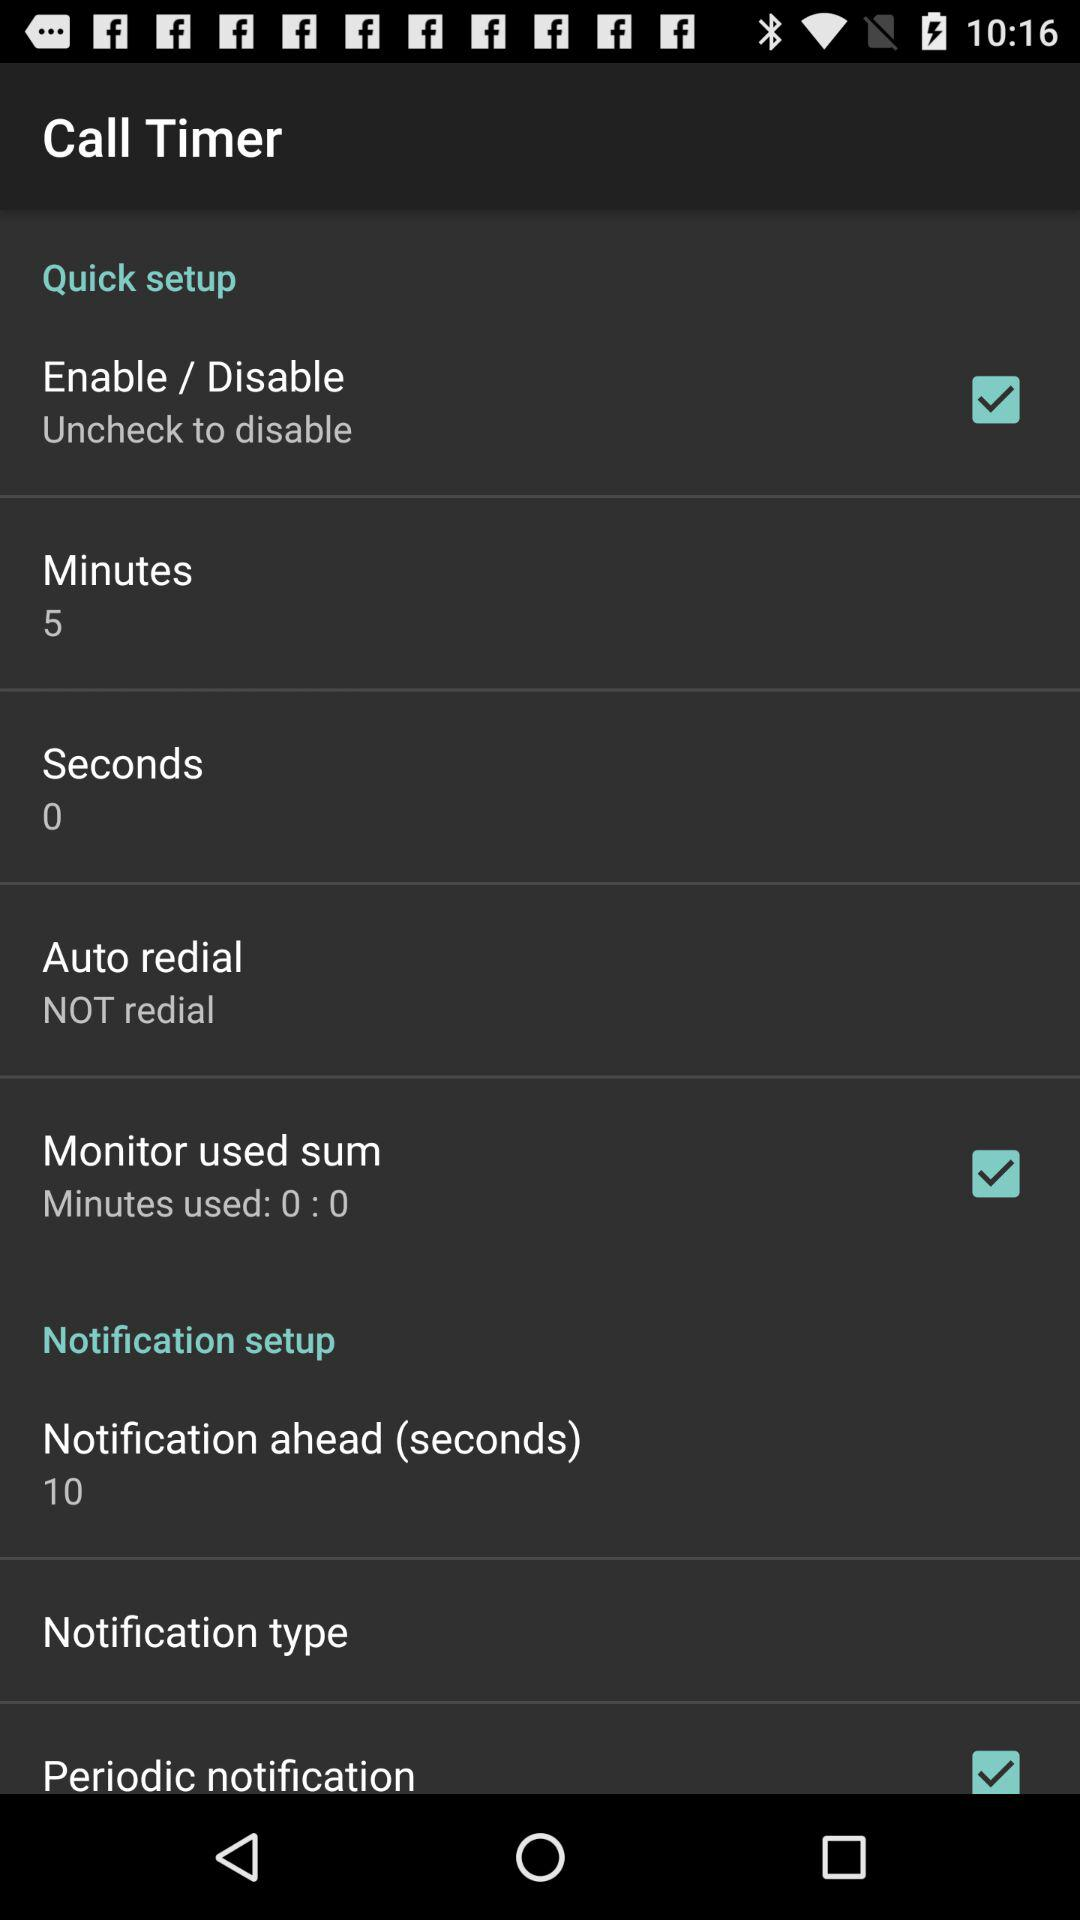What is the status of seconds?
When the provided information is insufficient, respond with <no answer>. <no answer> 